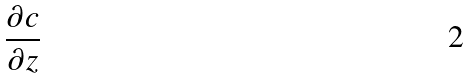Convert formula to latex. <formula><loc_0><loc_0><loc_500><loc_500>\frac { \partial c } { \partial z }</formula> 